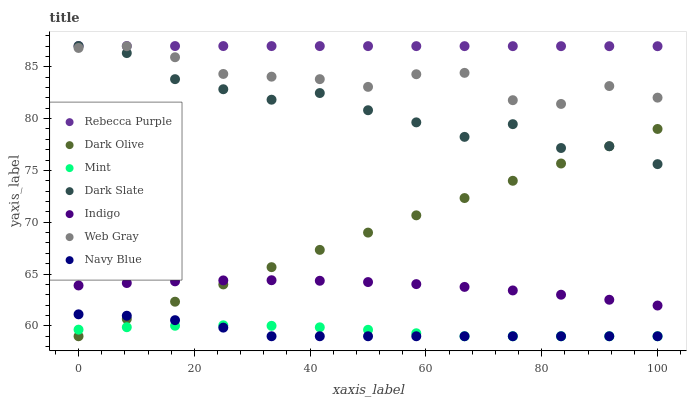Does Navy Blue have the minimum area under the curve?
Answer yes or no. Yes. Does Rebecca Purple have the maximum area under the curve?
Answer yes or no. Yes. Does Indigo have the minimum area under the curve?
Answer yes or no. No. Does Indigo have the maximum area under the curve?
Answer yes or no. No. Is Dark Olive the smoothest?
Answer yes or no. Yes. Is Dark Slate the roughest?
Answer yes or no. Yes. Is Indigo the smoothest?
Answer yes or no. No. Is Indigo the roughest?
Answer yes or no. No. Does Navy Blue have the lowest value?
Answer yes or no. Yes. Does Indigo have the lowest value?
Answer yes or no. No. Does Rebecca Purple have the highest value?
Answer yes or no. Yes. Does Indigo have the highest value?
Answer yes or no. No. Is Mint less than Rebecca Purple?
Answer yes or no. Yes. Is Dark Slate greater than Mint?
Answer yes or no. Yes. Does Dark Slate intersect Web Gray?
Answer yes or no. Yes. Is Dark Slate less than Web Gray?
Answer yes or no. No. Is Dark Slate greater than Web Gray?
Answer yes or no. No. Does Mint intersect Rebecca Purple?
Answer yes or no. No. 